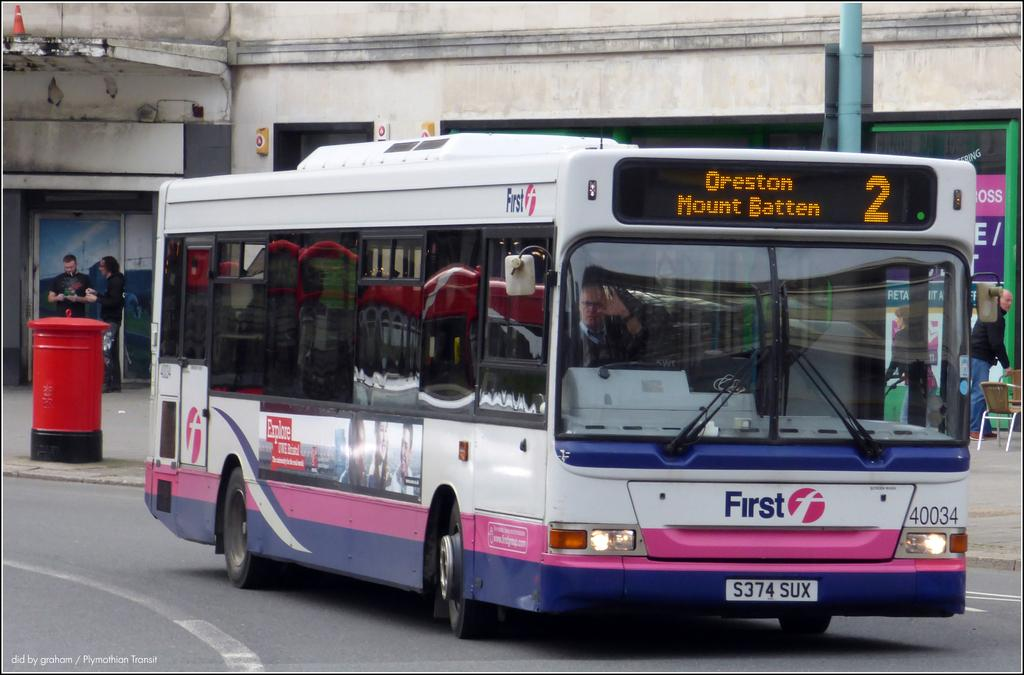Provide a one-sentence caption for the provided image. A bus on a road that has an ad for First on the front of the bus. 